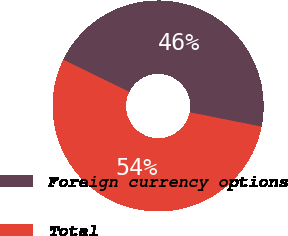Convert chart. <chart><loc_0><loc_0><loc_500><loc_500><pie_chart><fcel>Foreign currency options<fcel>Total<nl><fcel>45.92%<fcel>54.08%<nl></chart> 